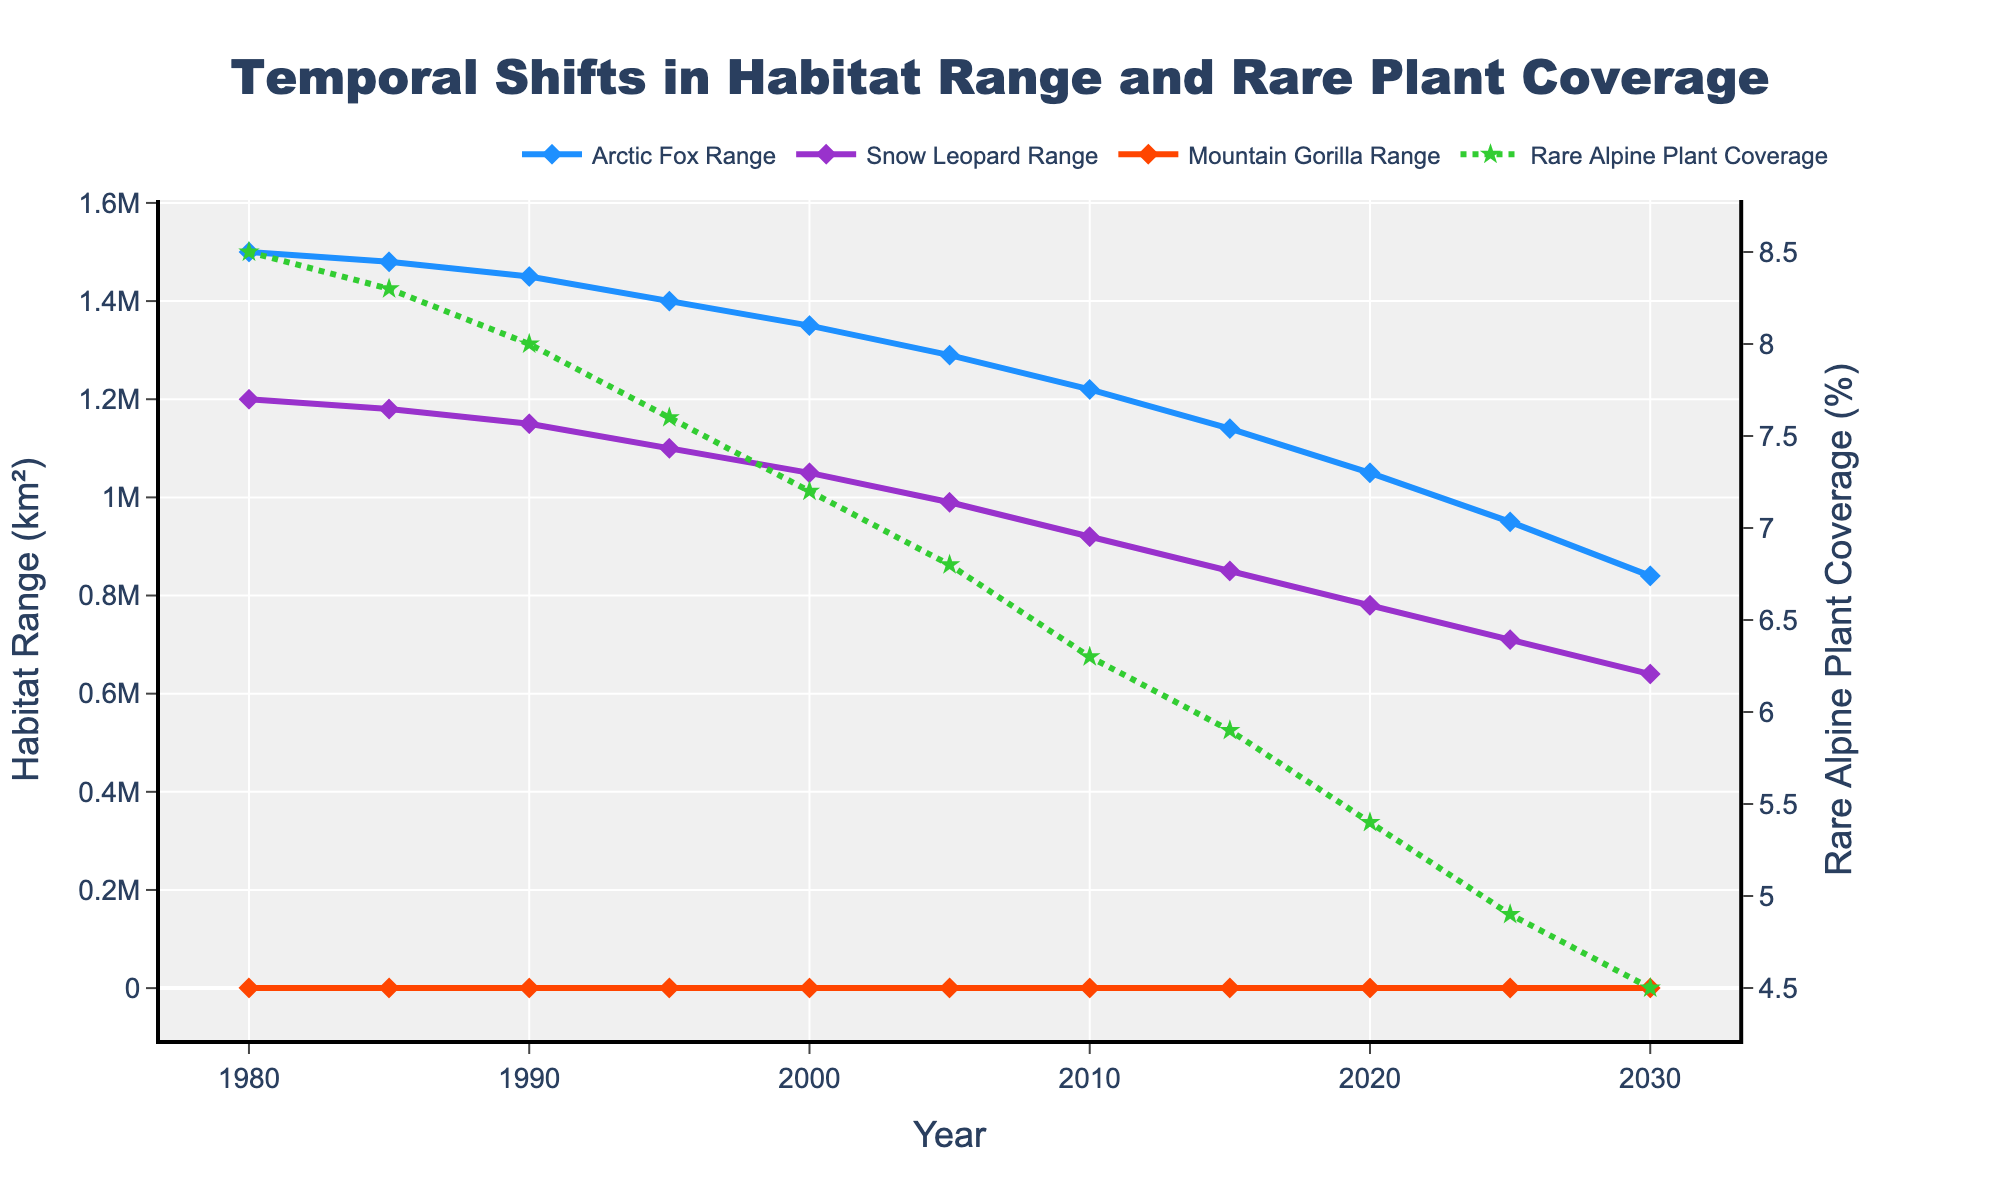Which animal species experienced the greatest decrease in habitat range from 1980 to 2030? To answer this question, observe the starting and ending points of each animal's range on the plot. The Arctic Fox's range decreased from 1,500,000 km² to 840,000 km², a difference of 660,000 km². The Snow Leopard's range decreased from 1,200,000 km² to 640,000 km², a difference of 560,000 km². The Mountain Gorilla's range decreased from 375 km² to 230 km², a difference of 145 km². Thus, the Arctic Fox experienced the greatest decrease.
Answer: Arctic Fox How did the trends in habitat range for the Arctic Fox and Snow Leopard compare between 1980 and 2000? Look for the lines corresponding to the Arctic Fox and Snow Leopard between 1980 and 2000. The Arctic Fox's habitat range decreased from 1,500,000 km² to 1,350,000 km², while the Snow Leopard's range decreased from 1,200,000 km² to 1,050,000 km² during the same period. Both species showed a decreasing trend.
Answer: Both decreased What is the average yearly decrease in habitat range for the Mountain Gorilla from 1980 to 2030? First, calculate the total decrease: 375 km² in 1980 minus 230 km² in 2030 is a 145 km² decrease. Since this change happens over 50 years (2030-1980), the average yearly decrease equals 145 km² divided by 50 years.
Answer: 2.9 km² per year Compare the trend in rare alpine plant coverage to Mountain Gorilla habitat range from 1980 to 2030. How do their changes relate? The plot shows both rare alpine plant coverage (dashed green line) and Mountain Gorilla habitat range (orange line) from 1980 to 2030. The plant coverage decreases from 8.5% to 4.5%, and the gorilla range decreases from 375 km² to 230 km². Both variables show a decreasing trend over time.
Answer: Both decrease By how much did the rare alpine plant coverage decrease from 1980 to 2020? Find the plant coverage values for 1980 and 2020: 8.5% in 1980 and 5.4% in 2020. To find the decrease, subtract the 2020 value from the 1980 value: 8.5% - 5.4%.
Answer: 3.1% In which period did the Snow Leopard experience the steepest decline in habitat range? Visually identify the steepest downward slope in the Snow Leopard's blue line on the chart. The period from 2005 to 2010 appears steep, where the range drops from 990,000 km² to 920,000 km².
Answer: 2005 to 2010 Compare the ending plant coverage percentage in 2030 to the Arctic Fox's habitat range in the same year. Which saw a greater percentage decrease relative to their starting values? The rare alpine plant coverage decreased from 8.5% to 4.5%, a 47.06% decrease [((8.5-4.5)/8.5)*100]. The Arctic Fox habitat range decreased from 1,500,000 km² to 840,000 km², a 44% decrease [((1,500,000-840,000)/1,500,000)*100]. Thus, the plant coverage saw a greater percentage decrease.
Answer: Plant coverage During which year were the declines in all species' habitat ranges the smallest? Observe the slopes in the lines corresponding to each species and identify the year with the smallest collective negative change. Between 1980 and 1985, the declines appear relatively small: Arctic Fox (-20,000 km²), Snow Leopard (-20,000 km²), Mountain Gorilla (-15 km²).
Answer: 1985 